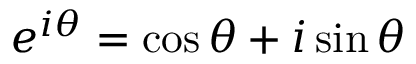Convert formula to latex. <formula><loc_0><loc_0><loc_500><loc_500>e ^ { i \theta } = \cos \theta + i \sin \theta</formula> 